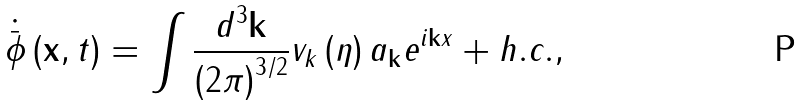Convert formula to latex. <formula><loc_0><loc_0><loc_500><loc_500>\dot { \bar { \phi } } \left ( { \mathbf x } , t \right ) = \int \frac { d ^ { 3 } { \mathbf k } } { \left ( 2 \pi \right ) ^ { 3 / 2 } } v _ { k } \left ( \eta \right ) a _ { \mathbf k } e ^ { i { \mathbf k x } } + h . c . ,</formula> 